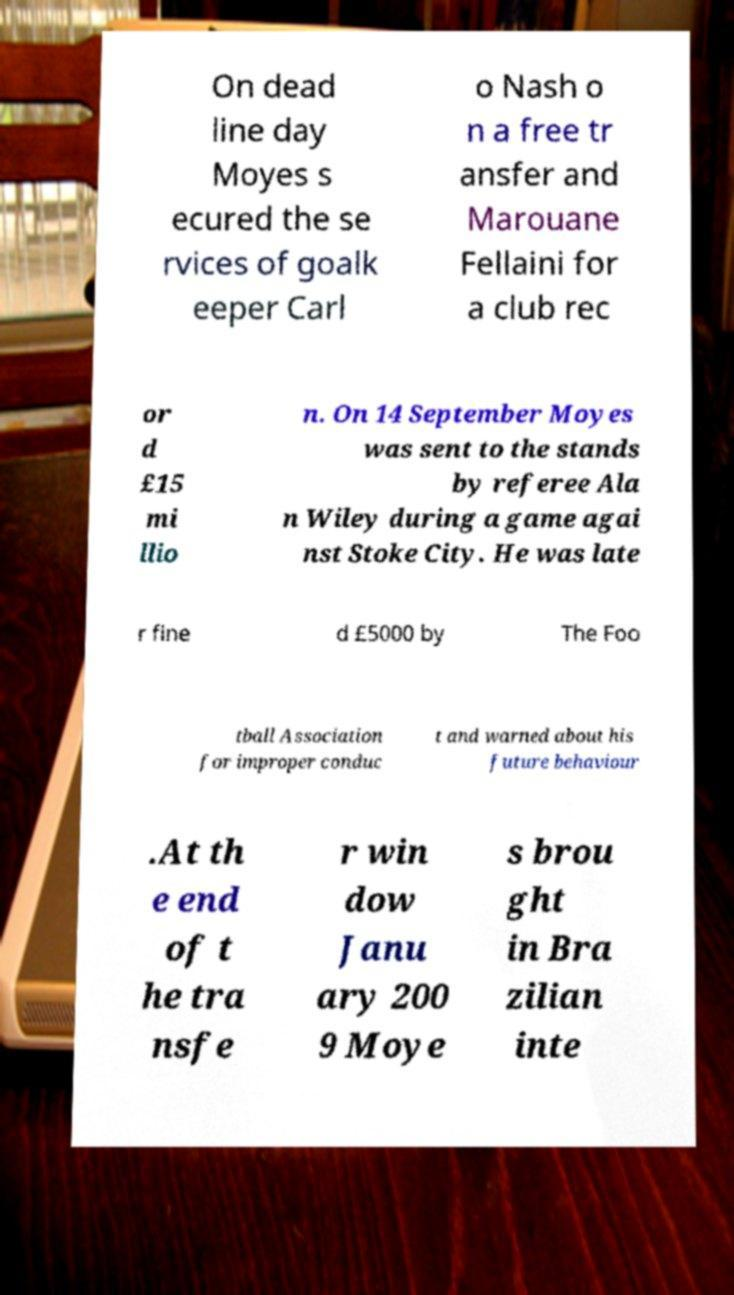Please read and relay the text visible in this image. What does it say? On dead line day Moyes s ecured the se rvices of goalk eeper Carl o Nash o n a free tr ansfer and Marouane Fellaini for a club rec or d £15 mi llio n. On 14 September Moyes was sent to the stands by referee Ala n Wiley during a game agai nst Stoke City. He was late r fine d £5000 by The Foo tball Association for improper conduc t and warned about his future behaviour .At th e end of t he tra nsfe r win dow Janu ary 200 9 Moye s brou ght in Bra zilian inte 